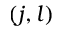Convert formula to latex. <formula><loc_0><loc_0><loc_500><loc_500>( j , l )</formula> 